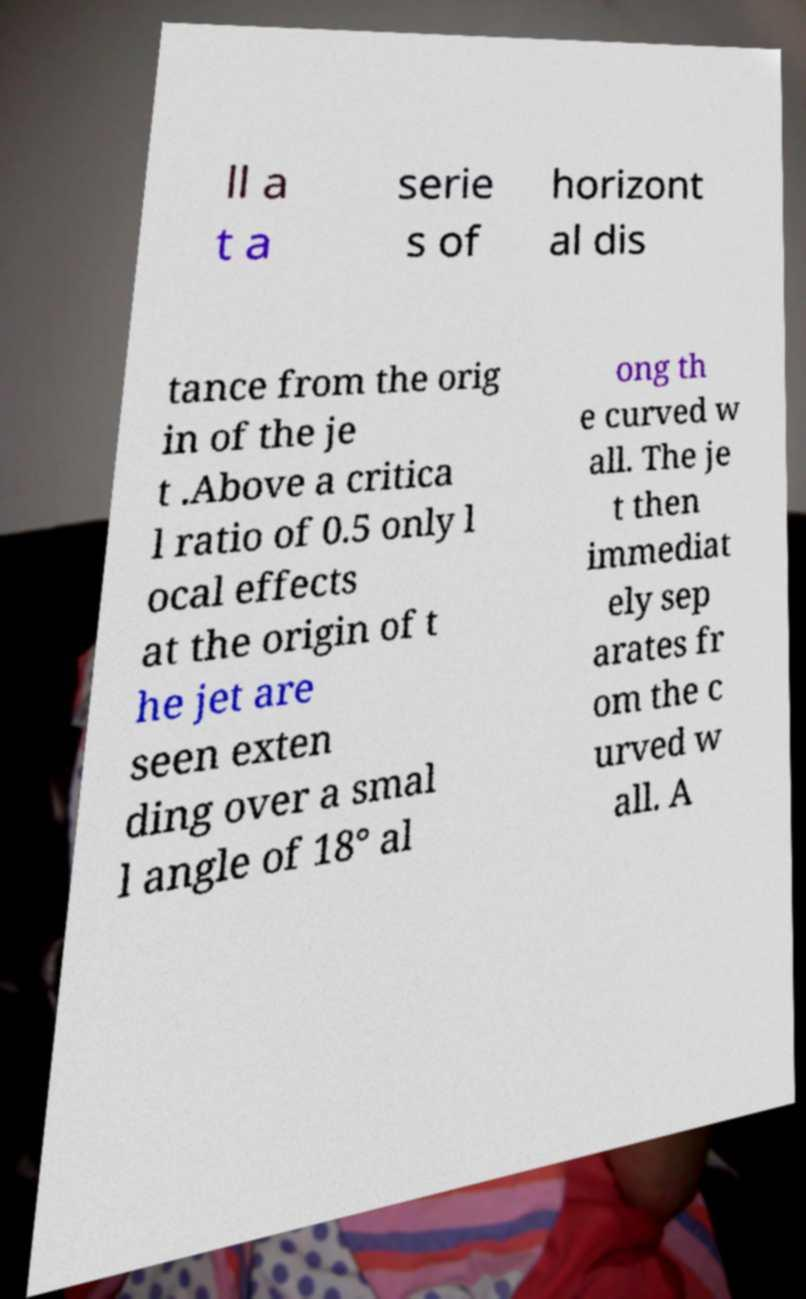There's text embedded in this image that I need extracted. Can you transcribe it verbatim? ll a t a serie s of horizont al dis tance from the orig in of the je t .Above a critica l ratio of 0.5 only l ocal effects at the origin of t he jet are seen exten ding over a smal l angle of 18° al ong th e curved w all. The je t then immediat ely sep arates fr om the c urved w all. A 